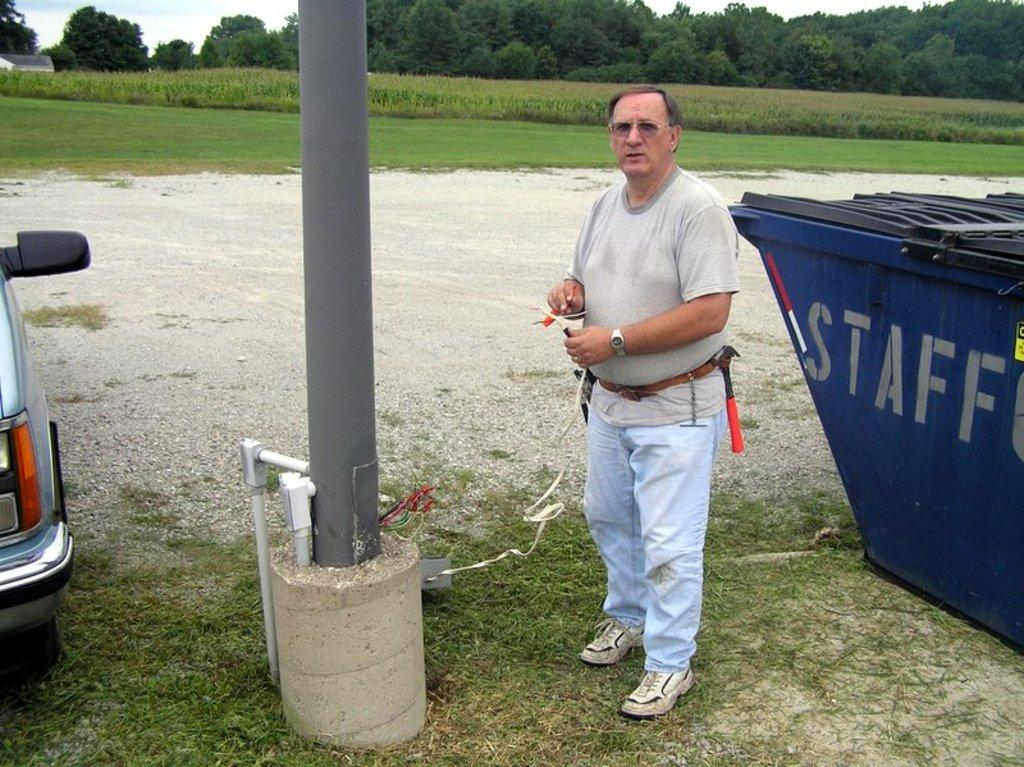<image>
Describe the image concisely. man standing next to a garbage can which says "STAFF" on it. 